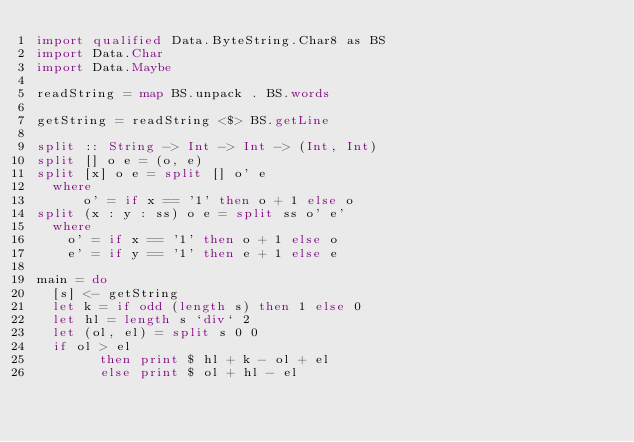Convert code to text. <code><loc_0><loc_0><loc_500><loc_500><_Haskell_>import qualified Data.ByteString.Char8 as BS
import Data.Char
import Data.Maybe

readString = map BS.unpack . BS.words

getString = readString <$> BS.getLine

split :: String -> Int -> Int -> (Int, Int)
split [] o e = (o, e)
split [x] o e = split [] o' e
  where
      o' = if x == '1' then o + 1 else o
split (x : y : ss) o e = split ss o' e'
  where
    o' = if x == '1' then o + 1 else o
    e' = if y == '1' then e + 1 else e
    
main = do
  [s] <- getString
  let k = if odd (length s) then 1 else 0
  let hl = length s `div` 2
  let (ol, el) = split s 0 0
  if ol > el
        then print $ hl + k - ol + el
        else print $ ol + hl - el
          </code> 